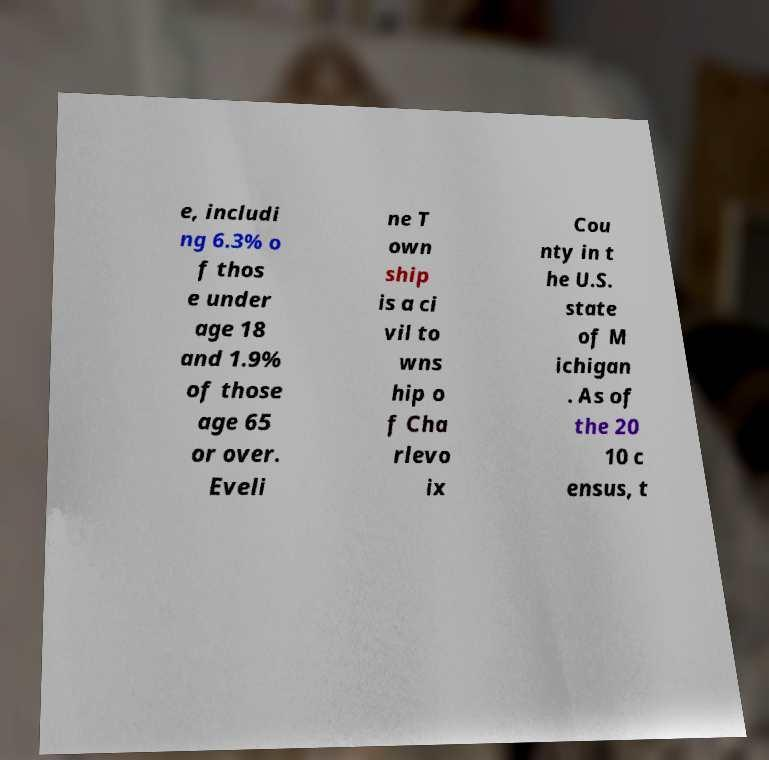Can you accurately transcribe the text from the provided image for me? e, includi ng 6.3% o f thos e under age 18 and 1.9% of those age 65 or over. Eveli ne T own ship is a ci vil to wns hip o f Cha rlevo ix Cou nty in t he U.S. state of M ichigan . As of the 20 10 c ensus, t 